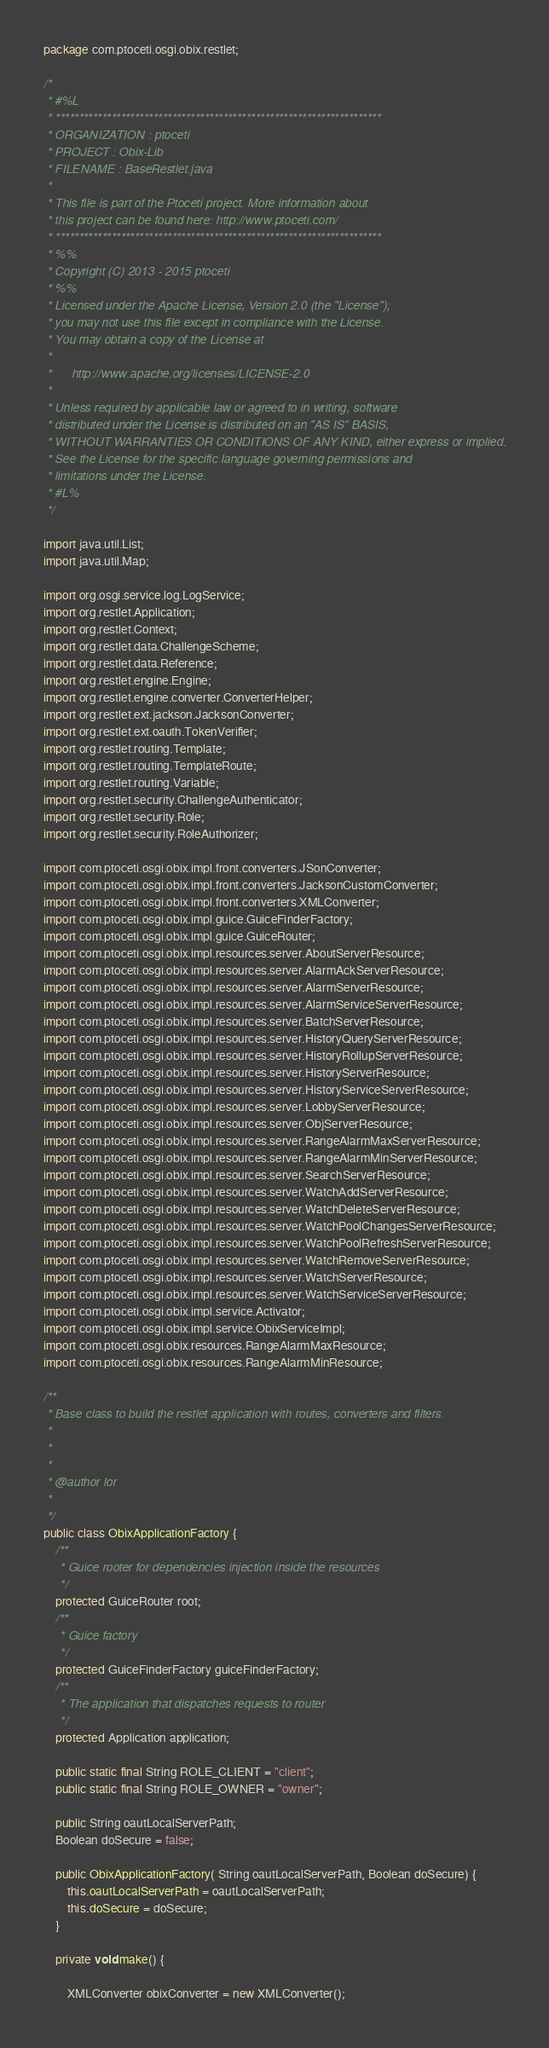Convert code to text. <code><loc_0><loc_0><loc_500><loc_500><_Java_>package com.ptoceti.osgi.obix.restlet;

/*
 * #%L
 * **********************************************************************
 * ORGANIZATION : ptoceti
 * PROJECT : Obix-Lib
 * FILENAME : BaseRestlet.java
 * 
 * This file is part of the Ptoceti project. More information about
 * this project can be found here: http://www.ptoceti.com/
 * **********************************************************************
 * %%
 * Copyright (C) 2013 - 2015 ptoceti
 * %%
 * Licensed under the Apache License, Version 2.0 (the "License");
 * you may not use this file except in compliance with the License.
 * You may obtain a copy of the License at
 * 
 *      http://www.apache.org/licenses/LICENSE-2.0
 * 
 * Unless required by applicable law or agreed to in writing, software
 * distributed under the License is distributed on an "AS IS" BASIS,
 * WITHOUT WARRANTIES OR CONDITIONS OF ANY KIND, either express or implied.
 * See the License for the specific language governing permissions and
 * limitations under the License.
 * #L%
 */

import java.util.List;
import java.util.Map;

import org.osgi.service.log.LogService;
import org.restlet.Application;
import org.restlet.Context;
import org.restlet.data.ChallengeScheme;
import org.restlet.data.Reference;
import org.restlet.engine.Engine;
import org.restlet.engine.converter.ConverterHelper;
import org.restlet.ext.jackson.JacksonConverter;
import org.restlet.ext.oauth.TokenVerifier;
import org.restlet.routing.Template;
import org.restlet.routing.TemplateRoute;
import org.restlet.routing.Variable;
import org.restlet.security.ChallengeAuthenticator;
import org.restlet.security.Role;
import org.restlet.security.RoleAuthorizer;

import com.ptoceti.osgi.obix.impl.front.converters.JSonConverter;
import com.ptoceti.osgi.obix.impl.front.converters.JacksonCustomConverter;
import com.ptoceti.osgi.obix.impl.front.converters.XMLConverter;
import com.ptoceti.osgi.obix.impl.guice.GuiceFinderFactory;
import com.ptoceti.osgi.obix.impl.guice.GuiceRouter;
import com.ptoceti.osgi.obix.impl.resources.server.AboutServerResource;
import com.ptoceti.osgi.obix.impl.resources.server.AlarmAckServerResource;
import com.ptoceti.osgi.obix.impl.resources.server.AlarmServerResource;
import com.ptoceti.osgi.obix.impl.resources.server.AlarmServiceServerResource;
import com.ptoceti.osgi.obix.impl.resources.server.BatchServerResource;
import com.ptoceti.osgi.obix.impl.resources.server.HistoryQueryServerResource;
import com.ptoceti.osgi.obix.impl.resources.server.HistoryRollupServerResource;
import com.ptoceti.osgi.obix.impl.resources.server.HistoryServerResource;
import com.ptoceti.osgi.obix.impl.resources.server.HistoryServiceServerResource;
import com.ptoceti.osgi.obix.impl.resources.server.LobbyServerResource;
import com.ptoceti.osgi.obix.impl.resources.server.ObjServerResource;
import com.ptoceti.osgi.obix.impl.resources.server.RangeAlarmMaxServerResource;
import com.ptoceti.osgi.obix.impl.resources.server.RangeAlarmMinServerResource;
import com.ptoceti.osgi.obix.impl.resources.server.SearchServerResource;
import com.ptoceti.osgi.obix.impl.resources.server.WatchAddServerResource;
import com.ptoceti.osgi.obix.impl.resources.server.WatchDeleteServerResource;
import com.ptoceti.osgi.obix.impl.resources.server.WatchPoolChangesServerResource;
import com.ptoceti.osgi.obix.impl.resources.server.WatchPoolRefreshServerResource;
import com.ptoceti.osgi.obix.impl.resources.server.WatchRemoveServerResource;
import com.ptoceti.osgi.obix.impl.resources.server.WatchServerResource;
import com.ptoceti.osgi.obix.impl.resources.server.WatchServiceServerResource;
import com.ptoceti.osgi.obix.impl.service.Activator;
import com.ptoceti.osgi.obix.impl.service.ObixServiceImpl;
import com.ptoceti.osgi.obix.resources.RangeAlarmMaxResource;
import com.ptoceti.osgi.obix.resources.RangeAlarmMinResource;

/**
 * Base class to build the restlet application with routes, converters and filters.
 * 
 * 
 * 
 * @author lor
 *
 */
public class ObixApplicationFactory {
	/**
	 * Guice rooter for dependencies injection inside the resources
	 */
	protected GuiceRouter root;
	/**
	 * Guice factory
	 */
	protected GuiceFinderFactory guiceFinderFactory;
	/**
	 * The application that dispatches requests to router
	 */
	protected Application application;
	
	public static final String ROLE_CLIENT = "client";
    public static final String ROLE_OWNER = "owner";
    
    public String oautLocalServerPath;
    Boolean doSecure = false;
	
    public ObixApplicationFactory( String oautLocalServerPath, Boolean doSecure) {
    	this.oautLocalServerPath = oautLocalServerPath;
    	this.doSecure = doSecure;
    }
    
	private void make() {
		
		XMLConverter obixConverter = new XMLConverter();</code> 